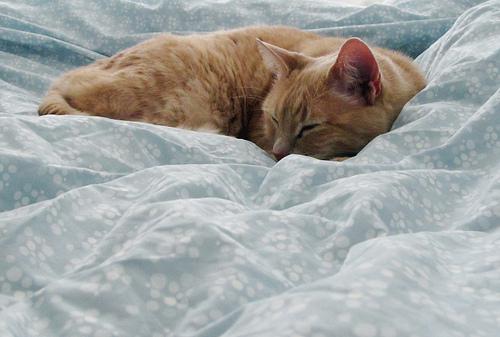Is the cat cute?
Keep it brief. Yes. What color is the bedding?
Keep it brief. Blue. Why is this cat on the bed?
Quick response, please. Sleeping. 